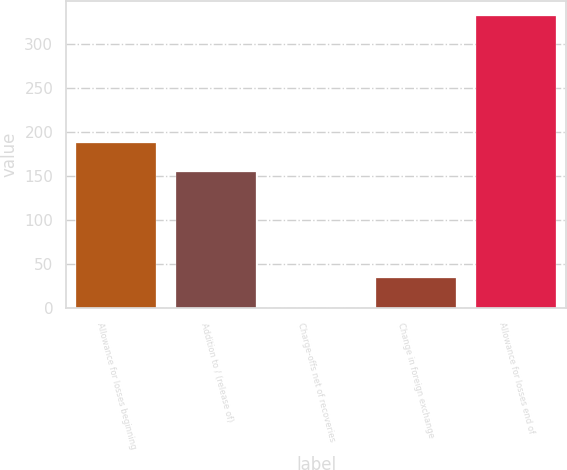Convert chart. <chart><loc_0><loc_0><loc_500><loc_500><bar_chart><fcel>Allowance for losses beginning<fcel>Addition to / (release of)<fcel>Charge-offs net of recoveries<fcel>Change in foreign exchange<fcel>Allowance for losses end of<nl><fcel>188.1<fcel>155<fcel>1<fcel>34.1<fcel>332<nl></chart> 